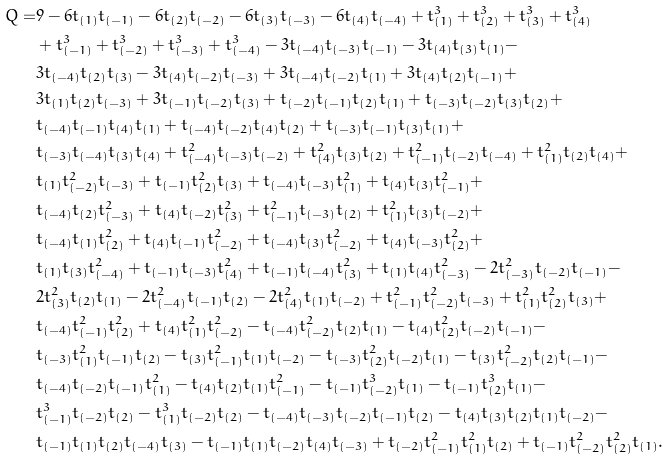<formula> <loc_0><loc_0><loc_500><loc_500>Q = & 9 - 6 t _ { ( 1 ) } t _ { ( - 1 ) } - 6 t _ { ( 2 ) } t _ { ( - 2 ) } - 6 t _ { ( 3 ) } t _ { ( - 3 ) } - 6 t _ { ( 4 ) } t _ { ( - 4 ) } + t _ { ( 1 ) } ^ { 3 } + t _ { ( 2 ) } ^ { 3 } + t _ { ( 3 ) } ^ { 3 } + t _ { ( 4 ) } ^ { 3 } \\ & + t _ { ( - 1 ) } ^ { 3 } + t _ { ( - 2 ) } ^ { 3 } + t _ { ( - 3 ) } ^ { 3 } + t _ { ( - 4 ) } ^ { 3 } - 3 t _ { ( - 4 ) } t _ { ( - 3 ) } t _ { ( - 1 ) } - 3 t _ { ( 4 ) } t _ { ( 3 ) } t _ { ( 1 ) } - \\ & 3 t _ { ( - 4 ) } t _ { ( 2 ) } t _ { ( 3 ) } - 3 t _ { ( 4 ) } t _ { ( - 2 ) } t _ { ( - 3 ) } + 3 t _ { ( - 4 ) } t _ { ( - 2 ) } t _ { ( 1 ) } + 3 t _ { ( 4 ) } t _ { ( 2 ) } t _ { ( - 1 ) } + \\ & 3 t _ { ( 1 ) } t _ { ( 2 ) } t _ { ( - 3 ) } + 3 t _ { ( - 1 ) } t _ { ( - 2 ) } t _ { ( 3 ) } + t _ { ( - 2 ) } t _ { ( - 1 ) } t _ { ( 2 ) } t _ { ( 1 ) } + t _ { ( - 3 ) } t _ { ( - 2 ) } t _ { ( 3 ) } t _ { ( 2 ) } + \\ & t _ { ( - 4 ) } t _ { ( - 1 ) } t _ { ( 4 ) } t _ { ( 1 ) } + t _ { ( - 4 ) } t _ { ( - 2 ) } t _ { ( 4 ) } t _ { ( 2 ) } + t _ { ( - 3 ) } t _ { ( - 1 ) } t _ { ( 3 ) } t _ { ( 1 ) } + \\ & t _ { ( - 3 ) } t _ { ( - 4 ) } t _ { ( 3 ) } t _ { ( 4 ) } + t _ { ( - 4 ) } ^ { 2 } t _ { ( - 3 ) } t _ { ( - 2 ) } + t _ { ( 4 ) } ^ { 2 } t _ { ( 3 ) } t _ { ( 2 ) } + t _ { ( - 1 ) } ^ { 2 } t _ { ( - 2 ) } t _ { ( - 4 ) } + t _ { ( 1 ) } ^ { 2 } t _ { ( 2 ) } t _ { ( 4 ) } + \\ & t _ { ( 1 ) } t _ { ( - 2 ) } ^ { 2 } t _ { ( - 3 ) } + t _ { ( - 1 ) } t _ { ( 2 ) } ^ { 2 } t _ { ( 3 ) } + t _ { ( - 4 ) } t _ { ( - 3 ) } t _ { ( 1 ) } ^ { 2 } + t _ { ( 4 ) } t _ { ( 3 ) } t _ { ( - 1 ) } ^ { 2 } + \\ & t _ { ( - 4 ) } t _ { ( 2 ) } t _ { ( - 3 ) } ^ { 2 } + t _ { ( 4 ) } t _ { ( - 2 ) } t _ { ( 3 ) } ^ { 2 } + t _ { ( - 1 ) } ^ { 2 } t _ { ( - 3 ) } t _ { ( 2 ) } + t _ { ( 1 ) } ^ { 2 } t _ { ( 3 ) } t _ { ( - 2 ) } + \\ & t _ { ( - 4 ) } t _ { ( 1 ) } t _ { ( 2 ) } ^ { 2 } + t _ { ( 4 ) } t _ { ( - 1 ) } t _ { ( - 2 ) } ^ { 2 } + t _ { ( - 4 ) } t _ { ( 3 ) } t _ { ( - 2 ) } ^ { 2 } + t _ { ( 4 ) } t _ { ( - 3 ) } t _ { ( 2 ) } ^ { 2 } + \\ & t _ { ( 1 ) } t _ { ( 3 ) } t _ { ( - 4 ) } ^ { 2 } + t _ { ( - 1 ) } t _ { ( - 3 ) } t _ { ( 4 ) } ^ { 2 } + t _ { ( - 1 ) } t _ { ( - 4 ) } t _ { ( 3 ) } ^ { 2 } + t _ { ( 1 ) } t _ { ( 4 ) } t _ { ( - 3 ) } ^ { 2 } - 2 t _ { ( - 3 ) } ^ { 2 } t _ { ( - 2 ) } t _ { ( - 1 ) } - \\ & 2 t _ { ( 3 ) } ^ { 2 } t _ { ( 2 ) } t _ { ( 1 ) } - 2 t _ { ( - 4 ) } ^ { 2 } t _ { ( - 1 ) } t _ { ( 2 ) } - 2 t _ { ( 4 ) } ^ { 2 } t _ { ( 1 ) } t _ { ( - 2 ) } + t _ { ( - 1 ) } ^ { 2 } t _ { ( - 2 ) } ^ { 2 } t _ { ( - 3 ) } + t _ { ( 1 ) } ^ { 2 } t _ { ( 2 ) } ^ { 2 } t _ { ( 3 ) } + \\ & t _ { ( - 4 ) } t _ { ( - 1 ) } ^ { 2 } t _ { ( 2 ) } ^ { 2 } + t _ { ( 4 ) } t _ { ( 1 ) } ^ { 2 } t _ { ( - 2 ) } ^ { 2 } - t _ { ( - 4 ) } t _ { ( - 2 ) } ^ { 2 } t _ { ( 2 ) } t _ { ( 1 ) } - t _ { ( 4 ) } t _ { ( 2 ) } ^ { 2 } t _ { ( - 2 ) } t _ { ( - 1 ) } - \\ & t _ { ( - 3 ) } t _ { ( 1 ) } ^ { 2 } t _ { ( - 1 ) } t _ { ( 2 ) } - t _ { ( 3 ) } t _ { ( - 1 ) } ^ { 2 } t _ { ( 1 ) } t _ { ( - 2 ) } - t _ { ( - 3 ) } t _ { ( 2 ) } ^ { 2 } t _ { ( - 2 ) } t _ { ( 1 ) } - t _ { ( 3 ) } t _ { ( - 2 ) } ^ { 2 } t _ { ( 2 ) } t _ { ( - 1 ) } - \\ & t _ { ( - 4 ) } t _ { ( - 2 ) } t _ { ( - 1 ) } t _ { ( 1 ) } ^ { 2 } - t _ { ( 4 ) } t _ { ( 2 ) } t _ { ( 1 ) } t _ { ( - 1 ) } ^ { 2 } - t _ { ( - 1 ) } t _ { ( - 2 ) } ^ { 3 } t _ { ( 1 ) } - t _ { ( - 1 ) } t _ { ( 2 ) } ^ { 3 } t _ { ( 1 ) } - \\ & t _ { ( - 1 ) } ^ { 3 } t _ { ( - 2 ) } t _ { ( 2 ) } - t _ { ( 1 ) } ^ { 3 } t _ { ( - 2 ) } t _ { ( 2 ) } - t _ { ( - 4 ) } t _ { ( - 3 ) } t _ { ( - 2 ) } t _ { ( - 1 ) } t _ { ( 2 ) } - t _ { ( 4 ) } t _ { ( 3 ) } t _ { ( 2 ) } t _ { ( 1 ) } t _ { ( - 2 ) } - \\ & t _ { ( - 1 ) } t _ { ( 1 ) } t _ { ( 2 ) } t _ { ( - 4 ) } t _ { ( 3 ) } - t _ { ( - 1 ) } t _ { ( 1 ) } t _ { ( - 2 ) } t _ { ( 4 ) } t _ { ( - 3 ) } + t _ { ( - 2 ) } t _ { ( - 1 ) } ^ { 2 } t _ { ( 1 ) } ^ { 2 } t _ { ( 2 ) } + t _ { ( - 1 ) } t _ { ( - 2 ) } ^ { 2 } t _ { ( 2 ) } ^ { 2 } t _ { ( 1 ) } .</formula> 